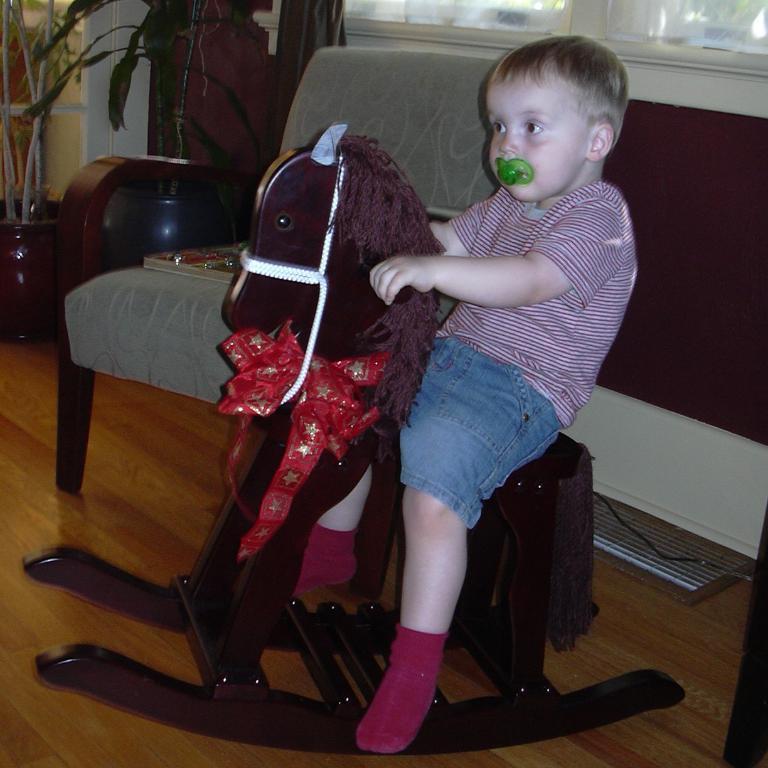Describe this image in one or two sentences. In this image we can see a boy is sitting on a horse toy and kept something in his mouth. 